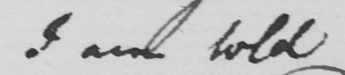Transcribe the text shown in this historical manuscript line. I am told 